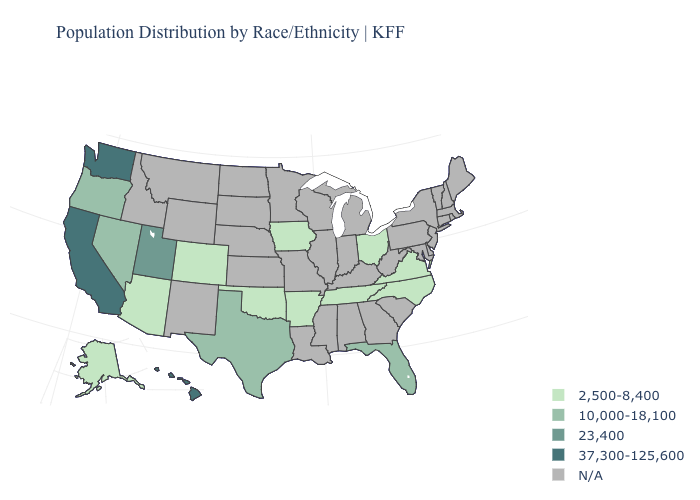What is the value of Maryland?
Quick response, please. N/A. What is the value of Oregon?
Quick response, please. 10,000-18,100. Name the states that have a value in the range 23,400?
Write a very short answer. Utah. How many symbols are there in the legend?
Short answer required. 5. Name the states that have a value in the range N/A?
Give a very brief answer. Alabama, Connecticut, Delaware, Georgia, Idaho, Illinois, Indiana, Kansas, Kentucky, Louisiana, Maine, Maryland, Massachusetts, Michigan, Minnesota, Mississippi, Missouri, Montana, Nebraska, New Hampshire, New Jersey, New Mexico, New York, North Dakota, Pennsylvania, Rhode Island, South Carolina, South Dakota, Vermont, West Virginia, Wisconsin, Wyoming. Among the states that border Illinois , which have the lowest value?
Short answer required. Iowa. Among the states that border Georgia , which have the highest value?
Write a very short answer. Florida. Is the legend a continuous bar?
Short answer required. No. Among the states that border Oklahoma , does Colorado have the lowest value?
Quick response, please. Yes. Which states have the highest value in the USA?
Answer briefly. California, Hawaii, Washington. What is the value of Georgia?
Keep it brief. N/A. Does California have the highest value in the West?
Answer briefly. Yes. What is the lowest value in states that border Georgia?
Answer briefly. 2,500-8,400. What is the value of Maine?
Write a very short answer. N/A. 